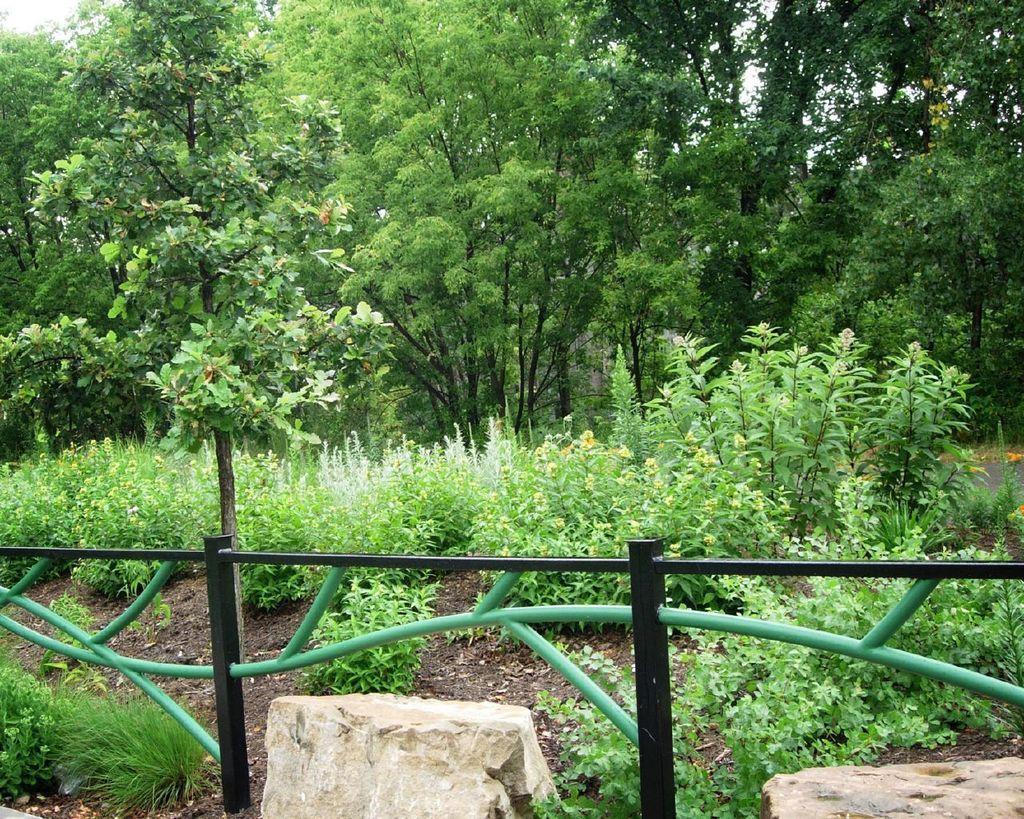In one or two sentences, can you explain what this image depicts? In this image I can see Iron railing, two stones, grass and plants in the front. In the background I can see number of trees and the sky. 